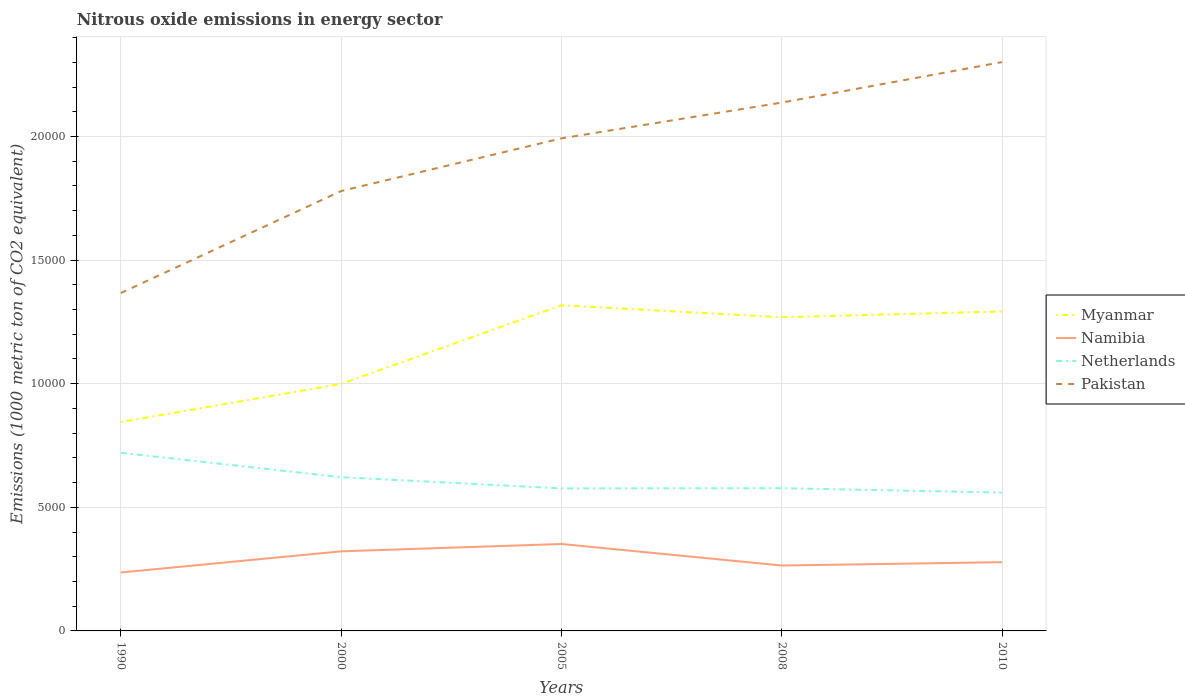How many different coloured lines are there?
Offer a terse response. 4. Does the line corresponding to Myanmar intersect with the line corresponding to Netherlands?
Offer a very short reply. No. Across all years, what is the maximum amount of nitrous oxide emitted in Namibia?
Offer a terse response. 2363.8. In which year was the amount of nitrous oxide emitted in Netherlands maximum?
Your answer should be compact. 2010. What is the total amount of nitrous oxide emitted in Namibia in the graph?
Offer a very short reply. -281.7. What is the difference between the highest and the second highest amount of nitrous oxide emitted in Netherlands?
Provide a succinct answer. 1608.7. Is the amount of nitrous oxide emitted in Namibia strictly greater than the amount of nitrous oxide emitted in Pakistan over the years?
Make the answer very short. Yes. How many lines are there?
Your answer should be compact. 4. What is the difference between two consecutive major ticks on the Y-axis?
Your answer should be compact. 5000. Does the graph contain any zero values?
Provide a short and direct response. No. Does the graph contain grids?
Offer a very short reply. Yes. Where does the legend appear in the graph?
Your answer should be compact. Center right. What is the title of the graph?
Offer a very short reply. Nitrous oxide emissions in energy sector. Does "Cameroon" appear as one of the legend labels in the graph?
Provide a short and direct response. No. What is the label or title of the X-axis?
Ensure brevity in your answer.  Years. What is the label or title of the Y-axis?
Your answer should be very brief. Emissions (1000 metric ton of CO2 equivalent). What is the Emissions (1000 metric ton of CO2 equivalent) of Myanmar in 1990?
Give a very brief answer. 8449.7. What is the Emissions (1000 metric ton of CO2 equivalent) of Namibia in 1990?
Provide a short and direct response. 2363.8. What is the Emissions (1000 metric ton of CO2 equivalent) in Netherlands in 1990?
Make the answer very short. 7205. What is the Emissions (1000 metric ton of CO2 equivalent) of Pakistan in 1990?
Make the answer very short. 1.37e+04. What is the Emissions (1000 metric ton of CO2 equivalent) of Myanmar in 2000?
Keep it short and to the point. 9992.2. What is the Emissions (1000 metric ton of CO2 equivalent) of Namibia in 2000?
Give a very brief answer. 3218.7. What is the Emissions (1000 metric ton of CO2 equivalent) in Netherlands in 2000?
Make the answer very short. 6219.5. What is the Emissions (1000 metric ton of CO2 equivalent) of Pakistan in 2000?
Make the answer very short. 1.78e+04. What is the Emissions (1000 metric ton of CO2 equivalent) of Myanmar in 2005?
Provide a succinct answer. 1.32e+04. What is the Emissions (1000 metric ton of CO2 equivalent) of Namibia in 2005?
Give a very brief answer. 3516.8. What is the Emissions (1000 metric ton of CO2 equivalent) in Netherlands in 2005?
Your answer should be very brief. 5764.8. What is the Emissions (1000 metric ton of CO2 equivalent) of Pakistan in 2005?
Provide a short and direct response. 1.99e+04. What is the Emissions (1000 metric ton of CO2 equivalent) in Myanmar in 2008?
Your answer should be compact. 1.27e+04. What is the Emissions (1000 metric ton of CO2 equivalent) in Namibia in 2008?
Offer a terse response. 2645.5. What is the Emissions (1000 metric ton of CO2 equivalent) of Netherlands in 2008?
Ensure brevity in your answer.  5773.6. What is the Emissions (1000 metric ton of CO2 equivalent) of Pakistan in 2008?
Your answer should be compact. 2.14e+04. What is the Emissions (1000 metric ton of CO2 equivalent) in Myanmar in 2010?
Your answer should be compact. 1.29e+04. What is the Emissions (1000 metric ton of CO2 equivalent) of Namibia in 2010?
Offer a terse response. 2780.9. What is the Emissions (1000 metric ton of CO2 equivalent) in Netherlands in 2010?
Provide a short and direct response. 5596.3. What is the Emissions (1000 metric ton of CO2 equivalent) in Pakistan in 2010?
Offer a terse response. 2.30e+04. Across all years, what is the maximum Emissions (1000 metric ton of CO2 equivalent) in Myanmar?
Offer a very short reply. 1.32e+04. Across all years, what is the maximum Emissions (1000 metric ton of CO2 equivalent) of Namibia?
Give a very brief answer. 3516.8. Across all years, what is the maximum Emissions (1000 metric ton of CO2 equivalent) of Netherlands?
Your response must be concise. 7205. Across all years, what is the maximum Emissions (1000 metric ton of CO2 equivalent) of Pakistan?
Provide a succinct answer. 2.30e+04. Across all years, what is the minimum Emissions (1000 metric ton of CO2 equivalent) of Myanmar?
Offer a terse response. 8449.7. Across all years, what is the minimum Emissions (1000 metric ton of CO2 equivalent) of Namibia?
Your response must be concise. 2363.8. Across all years, what is the minimum Emissions (1000 metric ton of CO2 equivalent) of Netherlands?
Ensure brevity in your answer.  5596.3. Across all years, what is the minimum Emissions (1000 metric ton of CO2 equivalent) in Pakistan?
Make the answer very short. 1.37e+04. What is the total Emissions (1000 metric ton of CO2 equivalent) in Myanmar in the graph?
Provide a succinct answer. 5.72e+04. What is the total Emissions (1000 metric ton of CO2 equivalent) in Namibia in the graph?
Make the answer very short. 1.45e+04. What is the total Emissions (1000 metric ton of CO2 equivalent) in Netherlands in the graph?
Keep it short and to the point. 3.06e+04. What is the total Emissions (1000 metric ton of CO2 equivalent) in Pakistan in the graph?
Your answer should be very brief. 9.58e+04. What is the difference between the Emissions (1000 metric ton of CO2 equivalent) of Myanmar in 1990 and that in 2000?
Make the answer very short. -1542.5. What is the difference between the Emissions (1000 metric ton of CO2 equivalent) in Namibia in 1990 and that in 2000?
Offer a terse response. -854.9. What is the difference between the Emissions (1000 metric ton of CO2 equivalent) in Netherlands in 1990 and that in 2000?
Keep it short and to the point. 985.5. What is the difference between the Emissions (1000 metric ton of CO2 equivalent) of Pakistan in 1990 and that in 2000?
Offer a terse response. -4125.3. What is the difference between the Emissions (1000 metric ton of CO2 equivalent) in Myanmar in 1990 and that in 2005?
Offer a terse response. -4721.9. What is the difference between the Emissions (1000 metric ton of CO2 equivalent) of Namibia in 1990 and that in 2005?
Give a very brief answer. -1153. What is the difference between the Emissions (1000 metric ton of CO2 equivalent) in Netherlands in 1990 and that in 2005?
Offer a terse response. 1440.2. What is the difference between the Emissions (1000 metric ton of CO2 equivalent) in Pakistan in 1990 and that in 2005?
Offer a very short reply. -6255.8. What is the difference between the Emissions (1000 metric ton of CO2 equivalent) of Myanmar in 1990 and that in 2008?
Keep it short and to the point. -4238.8. What is the difference between the Emissions (1000 metric ton of CO2 equivalent) of Namibia in 1990 and that in 2008?
Give a very brief answer. -281.7. What is the difference between the Emissions (1000 metric ton of CO2 equivalent) in Netherlands in 1990 and that in 2008?
Offer a very short reply. 1431.4. What is the difference between the Emissions (1000 metric ton of CO2 equivalent) of Pakistan in 1990 and that in 2008?
Offer a terse response. -7703.6. What is the difference between the Emissions (1000 metric ton of CO2 equivalent) in Myanmar in 1990 and that in 2010?
Offer a terse response. -4473.4. What is the difference between the Emissions (1000 metric ton of CO2 equivalent) of Namibia in 1990 and that in 2010?
Your answer should be compact. -417.1. What is the difference between the Emissions (1000 metric ton of CO2 equivalent) in Netherlands in 1990 and that in 2010?
Offer a very short reply. 1608.7. What is the difference between the Emissions (1000 metric ton of CO2 equivalent) in Pakistan in 1990 and that in 2010?
Provide a short and direct response. -9341.2. What is the difference between the Emissions (1000 metric ton of CO2 equivalent) of Myanmar in 2000 and that in 2005?
Your answer should be very brief. -3179.4. What is the difference between the Emissions (1000 metric ton of CO2 equivalent) of Namibia in 2000 and that in 2005?
Offer a very short reply. -298.1. What is the difference between the Emissions (1000 metric ton of CO2 equivalent) of Netherlands in 2000 and that in 2005?
Your answer should be very brief. 454.7. What is the difference between the Emissions (1000 metric ton of CO2 equivalent) of Pakistan in 2000 and that in 2005?
Make the answer very short. -2130.5. What is the difference between the Emissions (1000 metric ton of CO2 equivalent) of Myanmar in 2000 and that in 2008?
Your response must be concise. -2696.3. What is the difference between the Emissions (1000 metric ton of CO2 equivalent) of Namibia in 2000 and that in 2008?
Your answer should be compact. 573.2. What is the difference between the Emissions (1000 metric ton of CO2 equivalent) of Netherlands in 2000 and that in 2008?
Provide a short and direct response. 445.9. What is the difference between the Emissions (1000 metric ton of CO2 equivalent) in Pakistan in 2000 and that in 2008?
Provide a short and direct response. -3578.3. What is the difference between the Emissions (1000 metric ton of CO2 equivalent) in Myanmar in 2000 and that in 2010?
Provide a succinct answer. -2930.9. What is the difference between the Emissions (1000 metric ton of CO2 equivalent) in Namibia in 2000 and that in 2010?
Offer a very short reply. 437.8. What is the difference between the Emissions (1000 metric ton of CO2 equivalent) of Netherlands in 2000 and that in 2010?
Give a very brief answer. 623.2. What is the difference between the Emissions (1000 metric ton of CO2 equivalent) of Pakistan in 2000 and that in 2010?
Offer a very short reply. -5215.9. What is the difference between the Emissions (1000 metric ton of CO2 equivalent) of Myanmar in 2005 and that in 2008?
Offer a terse response. 483.1. What is the difference between the Emissions (1000 metric ton of CO2 equivalent) in Namibia in 2005 and that in 2008?
Keep it short and to the point. 871.3. What is the difference between the Emissions (1000 metric ton of CO2 equivalent) of Netherlands in 2005 and that in 2008?
Ensure brevity in your answer.  -8.8. What is the difference between the Emissions (1000 metric ton of CO2 equivalent) of Pakistan in 2005 and that in 2008?
Offer a very short reply. -1447.8. What is the difference between the Emissions (1000 metric ton of CO2 equivalent) in Myanmar in 2005 and that in 2010?
Make the answer very short. 248.5. What is the difference between the Emissions (1000 metric ton of CO2 equivalent) in Namibia in 2005 and that in 2010?
Give a very brief answer. 735.9. What is the difference between the Emissions (1000 metric ton of CO2 equivalent) of Netherlands in 2005 and that in 2010?
Offer a terse response. 168.5. What is the difference between the Emissions (1000 metric ton of CO2 equivalent) in Pakistan in 2005 and that in 2010?
Your answer should be compact. -3085.4. What is the difference between the Emissions (1000 metric ton of CO2 equivalent) in Myanmar in 2008 and that in 2010?
Your answer should be compact. -234.6. What is the difference between the Emissions (1000 metric ton of CO2 equivalent) of Namibia in 2008 and that in 2010?
Your answer should be very brief. -135.4. What is the difference between the Emissions (1000 metric ton of CO2 equivalent) of Netherlands in 2008 and that in 2010?
Keep it short and to the point. 177.3. What is the difference between the Emissions (1000 metric ton of CO2 equivalent) in Pakistan in 2008 and that in 2010?
Offer a terse response. -1637.6. What is the difference between the Emissions (1000 metric ton of CO2 equivalent) in Myanmar in 1990 and the Emissions (1000 metric ton of CO2 equivalent) in Namibia in 2000?
Provide a short and direct response. 5231. What is the difference between the Emissions (1000 metric ton of CO2 equivalent) in Myanmar in 1990 and the Emissions (1000 metric ton of CO2 equivalent) in Netherlands in 2000?
Your answer should be compact. 2230.2. What is the difference between the Emissions (1000 metric ton of CO2 equivalent) in Myanmar in 1990 and the Emissions (1000 metric ton of CO2 equivalent) in Pakistan in 2000?
Provide a short and direct response. -9343.8. What is the difference between the Emissions (1000 metric ton of CO2 equivalent) in Namibia in 1990 and the Emissions (1000 metric ton of CO2 equivalent) in Netherlands in 2000?
Your answer should be compact. -3855.7. What is the difference between the Emissions (1000 metric ton of CO2 equivalent) of Namibia in 1990 and the Emissions (1000 metric ton of CO2 equivalent) of Pakistan in 2000?
Ensure brevity in your answer.  -1.54e+04. What is the difference between the Emissions (1000 metric ton of CO2 equivalent) of Netherlands in 1990 and the Emissions (1000 metric ton of CO2 equivalent) of Pakistan in 2000?
Give a very brief answer. -1.06e+04. What is the difference between the Emissions (1000 metric ton of CO2 equivalent) of Myanmar in 1990 and the Emissions (1000 metric ton of CO2 equivalent) of Namibia in 2005?
Ensure brevity in your answer.  4932.9. What is the difference between the Emissions (1000 metric ton of CO2 equivalent) of Myanmar in 1990 and the Emissions (1000 metric ton of CO2 equivalent) of Netherlands in 2005?
Ensure brevity in your answer.  2684.9. What is the difference between the Emissions (1000 metric ton of CO2 equivalent) in Myanmar in 1990 and the Emissions (1000 metric ton of CO2 equivalent) in Pakistan in 2005?
Provide a short and direct response. -1.15e+04. What is the difference between the Emissions (1000 metric ton of CO2 equivalent) in Namibia in 1990 and the Emissions (1000 metric ton of CO2 equivalent) in Netherlands in 2005?
Provide a succinct answer. -3401. What is the difference between the Emissions (1000 metric ton of CO2 equivalent) of Namibia in 1990 and the Emissions (1000 metric ton of CO2 equivalent) of Pakistan in 2005?
Give a very brief answer. -1.76e+04. What is the difference between the Emissions (1000 metric ton of CO2 equivalent) in Netherlands in 1990 and the Emissions (1000 metric ton of CO2 equivalent) in Pakistan in 2005?
Make the answer very short. -1.27e+04. What is the difference between the Emissions (1000 metric ton of CO2 equivalent) of Myanmar in 1990 and the Emissions (1000 metric ton of CO2 equivalent) of Namibia in 2008?
Offer a very short reply. 5804.2. What is the difference between the Emissions (1000 metric ton of CO2 equivalent) in Myanmar in 1990 and the Emissions (1000 metric ton of CO2 equivalent) in Netherlands in 2008?
Keep it short and to the point. 2676.1. What is the difference between the Emissions (1000 metric ton of CO2 equivalent) in Myanmar in 1990 and the Emissions (1000 metric ton of CO2 equivalent) in Pakistan in 2008?
Ensure brevity in your answer.  -1.29e+04. What is the difference between the Emissions (1000 metric ton of CO2 equivalent) in Namibia in 1990 and the Emissions (1000 metric ton of CO2 equivalent) in Netherlands in 2008?
Offer a very short reply. -3409.8. What is the difference between the Emissions (1000 metric ton of CO2 equivalent) in Namibia in 1990 and the Emissions (1000 metric ton of CO2 equivalent) in Pakistan in 2008?
Your response must be concise. -1.90e+04. What is the difference between the Emissions (1000 metric ton of CO2 equivalent) in Netherlands in 1990 and the Emissions (1000 metric ton of CO2 equivalent) in Pakistan in 2008?
Your answer should be very brief. -1.42e+04. What is the difference between the Emissions (1000 metric ton of CO2 equivalent) in Myanmar in 1990 and the Emissions (1000 metric ton of CO2 equivalent) in Namibia in 2010?
Give a very brief answer. 5668.8. What is the difference between the Emissions (1000 metric ton of CO2 equivalent) of Myanmar in 1990 and the Emissions (1000 metric ton of CO2 equivalent) of Netherlands in 2010?
Your response must be concise. 2853.4. What is the difference between the Emissions (1000 metric ton of CO2 equivalent) in Myanmar in 1990 and the Emissions (1000 metric ton of CO2 equivalent) in Pakistan in 2010?
Your answer should be very brief. -1.46e+04. What is the difference between the Emissions (1000 metric ton of CO2 equivalent) in Namibia in 1990 and the Emissions (1000 metric ton of CO2 equivalent) in Netherlands in 2010?
Your answer should be compact. -3232.5. What is the difference between the Emissions (1000 metric ton of CO2 equivalent) in Namibia in 1990 and the Emissions (1000 metric ton of CO2 equivalent) in Pakistan in 2010?
Offer a very short reply. -2.06e+04. What is the difference between the Emissions (1000 metric ton of CO2 equivalent) in Netherlands in 1990 and the Emissions (1000 metric ton of CO2 equivalent) in Pakistan in 2010?
Make the answer very short. -1.58e+04. What is the difference between the Emissions (1000 metric ton of CO2 equivalent) of Myanmar in 2000 and the Emissions (1000 metric ton of CO2 equivalent) of Namibia in 2005?
Provide a succinct answer. 6475.4. What is the difference between the Emissions (1000 metric ton of CO2 equivalent) in Myanmar in 2000 and the Emissions (1000 metric ton of CO2 equivalent) in Netherlands in 2005?
Your answer should be compact. 4227.4. What is the difference between the Emissions (1000 metric ton of CO2 equivalent) in Myanmar in 2000 and the Emissions (1000 metric ton of CO2 equivalent) in Pakistan in 2005?
Provide a short and direct response. -9931.8. What is the difference between the Emissions (1000 metric ton of CO2 equivalent) of Namibia in 2000 and the Emissions (1000 metric ton of CO2 equivalent) of Netherlands in 2005?
Give a very brief answer. -2546.1. What is the difference between the Emissions (1000 metric ton of CO2 equivalent) in Namibia in 2000 and the Emissions (1000 metric ton of CO2 equivalent) in Pakistan in 2005?
Make the answer very short. -1.67e+04. What is the difference between the Emissions (1000 metric ton of CO2 equivalent) of Netherlands in 2000 and the Emissions (1000 metric ton of CO2 equivalent) of Pakistan in 2005?
Ensure brevity in your answer.  -1.37e+04. What is the difference between the Emissions (1000 metric ton of CO2 equivalent) of Myanmar in 2000 and the Emissions (1000 metric ton of CO2 equivalent) of Namibia in 2008?
Your answer should be compact. 7346.7. What is the difference between the Emissions (1000 metric ton of CO2 equivalent) in Myanmar in 2000 and the Emissions (1000 metric ton of CO2 equivalent) in Netherlands in 2008?
Provide a succinct answer. 4218.6. What is the difference between the Emissions (1000 metric ton of CO2 equivalent) in Myanmar in 2000 and the Emissions (1000 metric ton of CO2 equivalent) in Pakistan in 2008?
Make the answer very short. -1.14e+04. What is the difference between the Emissions (1000 metric ton of CO2 equivalent) of Namibia in 2000 and the Emissions (1000 metric ton of CO2 equivalent) of Netherlands in 2008?
Your answer should be very brief. -2554.9. What is the difference between the Emissions (1000 metric ton of CO2 equivalent) of Namibia in 2000 and the Emissions (1000 metric ton of CO2 equivalent) of Pakistan in 2008?
Offer a terse response. -1.82e+04. What is the difference between the Emissions (1000 metric ton of CO2 equivalent) of Netherlands in 2000 and the Emissions (1000 metric ton of CO2 equivalent) of Pakistan in 2008?
Keep it short and to the point. -1.52e+04. What is the difference between the Emissions (1000 metric ton of CO2 equivalent) of Myanmar in 2000 and the Emissions (1000 metric ton of CO2 equivalent) of Namibia in 2010?
Provide a succinct answer. 7211.3. What is the difference between the Emissions (1000 metric ton of CO2 equivalent) in Myanmar in 2000 and the Emissions (1000 metric ton of CO2 equivalent) in Netherlands in 2010?
Provide a short and direct response. 4395.9. What is the difference between the Emissions (1000 metric ton of CO2 equivalent) in Myanmar in 2000 and the Emissions (1000 metric ton of CO2 equivalent) in Pakistan in 2010?
Give a very brief answer. -1.30e+04. What is the difference between the Emissions (1000 metric ton of CO2 equivalent) of Namibia in 2000 and the Emissions (1000 metric ton of CO2 equivalent) of Netherlands in 2010?
Provide a succinct answer. -2377.6. What is the difference between the Emissions (1000 metric ton of CO2 equivalent) in Namibia in 2000 and the Emissions (1000 metric ton of CO2 equivalent) in Pakistan in 2010?
Offer a very short reply. -1.98e+04. What is the difference between the Emissions (1000 metric ton of CO2 equivalent) of Netherlands in 2000 and the Emissions (1000 metric ton of CO2 equivalent) of Pakistan in 2010?
Your response must be concise. -1.68e+04. What is the difference between the Emissions (1000 metric ton of CO2 equivalent) in Myanmar in 2005 and the Emissions (1000 metric ton of CO2 equivalent) in Namibia in 2008?
Make the answer very short. 1.05e+04. What is the difference between the Emissions (1000 metric ton of CO2 equivalent) in Myanmar in 2005 and the Emissions (1000 metric ton of CO2 equivalent) in Netherlands in 2008?
Ensure brevity in your answer.  7398. What is the difference between the Emissions (1000 metric ton of CO2 equivalent) in Myanmar in 2005 and the Emissions (1000 metric ton of CO2 equivalent) in Pakistan in 2008?
Provide a succinct answer. -8200.2. What is the difference between the Emissions (1000 metric ton of CO2 equivalent) in Namibia in 2005 and the Emissions (1000 metric ton of CO2 equivalent) in Netherlands in 2008?
Keep it short and to the point. -2256.8. What is the difference between the Emissions (1000 metric ton of CO2 equivalent) of Namibia in 2005 and the Emissions (1000 metric ton of CO2 equivalent) of Pakistan in 2008?
Provide a short and direct response. -1.79e+04. What is the difference between the Emissions (1000 metric ton of CO2 equivalent) of Netherlands in 2005 and the Emissions (1000 metric ton of CO2 equivalent) of Pakistan in 2008?
Provide a succinct answer. -1.56e+04. What is the difference between the Emissions (1000 metric ton of CO2 equivalent) in Myanmar in 2005 and the Emissions (1000 metric ton of CO2 equivalent) in Namibia in 2010?
Give a very brief answer. 1.04e+04. What is the difference between the Emissions (1000 metric ton of CO2 equivalent) of Myanmar in 2005 and the Emissions (1000 metric ton of CO2 equivalent) of Netherlands in 2010?
Give a very brief answer. 7575.3. What is the difference between the Emissions (1000 metric ton of CO2 equivalent) of Myanmar in 2005 and the Emissions (1000 metric ton of CO2 equivalent) of Pakistan in 2010?
Keep it short and to the point. -9837.8. What is the difference between the Emissions (1000 metric ton of CO2 equivalent) in Namibia in 2005 and the Emissions (1000 metric ton of CO2 equivalent) in Netherlands in 2010?
Your answer should be very brief. -2079.5. What is the difference between the Emissions (1000 metric ton of CO2 equivalent) of Namibia in 2005 and the Emissions (1000 metric ton of CO2 equivalent) of Pakistan in 2010?
Offer a very short reply. -1.95e+04. What is the difference between the Emissions (1000 metric ton of CO2 equivalent) of Netherlands in 2005 and the Emissions (1000 metric ton of CO2 equivalent) of Pakistan in 2010?
Provide a succinct answer. -1.72e+04. What is the difference between the Emissions (1000 metric ton of CO2 equivalent) in Myanmar in 2008 and the Emissions (1000 metric ton of CO2 equivalent) in Namibia in 2010?
Provide a succinct answer. 9907.6. What is the difference between the Emissions (1000 metric ton of CO2 equivalent) in Myanmar in 2008 and the Emissions (1000 metric ton of CO2 equivalent) in Netherlands in 2010?
Give a very brief answer. 7092.2. What is the difference between the Emissions (1000 metric ton of CO2 equivalent) in Myanmar in 2008 and the Emissions (1000 metric ton of CO2 equivalent) in Pakistan in 2010?
Provide a succinct answer. -1.03e+04. What is the difference between the Emissions (1000 metric ton of CO2 equivalent) of Namibia in 2008 and the Emissions (1000 metric ton of CO2 equivalent) of Netherlands in 2010?
Provide a succinct answer. -2950.8. What is the difference between the Emissions (1000 metric ton of CO2 equivalent) in Namibia in 2008 and the Emissions (1000 metric ton of CO2 equivalent) in Pakistan in 2010?
Ensure brevity in your answer.  -2.04e+04. What is the difference between the Emissions (1000 metric ton of CO2 equivalent) in Netherlands in 2008 and the Emissions (1000 metric ton of CO2 equivalent) in Pakistan in 2010?
Your response must be concise. -1.72e+04. What is the average Emissions (1000 metric ton of CO2 equivalent) in Myanmar per year?
Keep it short and to the point. 1.14e+04. What is the average Emissions (1000 metric ton of CO2 equivalent) in Namibia per year?
Offer a terse response. 2905.14. What is the average Emissions (1000 metric ton of CO2 equivalent) of Netherlands per year?
Keep it short and to the point. 6111.84. What is the average Emissions (1000 metric ton of CO2 equivalent) in Pakistan per year?
Provide a succinct answer. 1.92e+04. In the year 1990, what is the difference between the Emissions (1000 metric ton of CO2 equivalent) in Myanmar and Emissions (1000 metric ton of CO2 equivalent) in Namibia?
Your answer should be very brief. 6085.9. In the year 1990, what is the difference between the Emissions (1000 metric ton of CO2 equivalent) in Myanmar and Emissions (1000 metric ton of CO2 equivalent) in Netherlands?
Provide a short and direct response. 1244.7. In the year 1990, what is the difference between the Emissions (1000 metric ton of CO2 equivalent) in Myanmar and Emissions (1000 metric ton of CO2 equivalent) in Pakistan?
Your answer should be compact. -5218.5. In the year 1990, what is the difference between the Emissions (1000 metric ton of CO2 equivalent) in Namibia and Emissions (1000 metric ton of CO2 equivalent) in Netherlands?
Ensure brevity in your answer.  -4841.2. In the year 1990, what is the difference between the Emissions (1000 metric ton of CO2 equivalent) of Namibia and Emissions (1000 metric ton of CO2 equivalent) of Pakistan?
Your response must be concise. -1.13e+04. In the year 1990, what is the difference between the Emissions (1000 metric ton of CO2 equivalent) in Netherlands and Emissions (1000 metric ton of CO2 equivalent) in Pakistan?
Keep it short and to the point. -6463.2. In the year 2000, what is the difference between the Emissions (1000 metric ton of CO2 equivalent) of Myanmar and Emissions (1000 metric ton of CO2 equivalent) of Namibia?
Provide a succinct answer. 6773.5. In the year 2000, what is the difference between the Emissions (1000 metric ton of CO2 equivalent) in Myanmar and Emissions (1000 metric ton of CO2 equivalent) in Netherlands?
Ensure brevity in your answer.  3772.7. In the year 2000, what is the difference between the Emissions (1000 metric ton of CO2 equivalent) of Myanmar and Emissions (1000 metric ton of CO2 equivalent) of Pakistan?
Make the answer very short. -7801.3. In the year 2000, what is the difference between the Emissions (1000 metric ton of CO2 equivalent) in Namibia and Emissions (1000 metric ton of CO2 equivalent) in Netherlands?
Your answer should be compact. -3000.8. In the year 2000, what is the difference between the Emissions (1000 metric ton of CO2 equivalent) in Namibia and Emissions (1000 metric ton of CO2 equivalent) in Pakistan?
Make the answer very short. -1.46e+04. In the year 2000, what is the difference between the Emissions (1000 metric ton of CO2 equivalent) of Netherlands and Emissions (1000 metric ton of CO2 equivalent) of Pakistan?
Provide a short and direct response. -1.16e+04. In the year 2005, what is the difference between the Emissions (1000 metric ton of CO2 equivalent) in Myanmar and Emissions (1000 metric ton of CO2 equivalent) in Namibia?
Your response must be concise. 9654.8. In the year 2005, what is the difference between the Emissions (1000 metric ton of CO2 equivalent) in Myanmar and Emissions (1000 metric ton of CO2 equivalent) in Netherlands?
Offer a terse response. 7406.8. In the year 2005, what is the difference between the Emissions (1000 metric ton of CO2 equivalent) of Myanmar and Emissions (1000 metric ton of CO2 equivalent) of Pakistan?
Your answer should be compact. -6752.4. In the year 2005, what is the difference between the Emissions (1000 metric ton of CO2 equivalent) of Namibia and Emissions (1000 metric ton of CO2 equivalent) of Netherlands?
Offer a terse response. -2248. In the year 2005, what is the difference between the Emissions (1000 metric ton of CO2 equivalent) in Namibia and Emissions (1000 metric ton of CO2 equivalent) in Pakistan?
Ensure brevity in your answer.  -1.64e+04. In the year 2005, what is the difference between the Emissions (1000 metric ton of CO2 equivalent) in Netherlands and Emissions (1000 metric ton of CO2 equivalent) in Pakistan?
Provide a succinct answer. -1.42e+04. In the year 2008, what is the difference between the Emissions (1000 metric ton of CO2 equivalent) of Myanmar and Emissions (1000 metric ton of CO2 equivalent) of Namibia?
Make the answer very short. 1.00e+04. In the year 2008, what is the difference between the Emissions (1000 metric ton of CO2 equivalent) in Myanmar and Emissions (1000 metric ton of CO2 equivalent) in Netherlands?
Offer a very short reply. 6914.9. In the year 2008, what is the difference between the Emissions (1000 metric ton of CO2 equivalent) in Myanmar and Emissions (1000 metric ton of CO2 equivalent) in Pakistan?
Provide a succinct answer. -8683.3. In the year 2008, what is the difference between the Emissions (1000 metric ton of CO2 equivalent) of Namibia and Emissions (1000 metric ton of CO2 equivalent) of Netherlands?
Offer a very short reply. -3128.1. In the year 2008, what is the difference between the Emissions (1000 metric ton of CO2 equivalent) in Namibia and Emissions (1000 metric ton of CO2 equivalent) in Pakistan?
Provide a short and direct response. -1.87e+04. In the year 2008, what is the difference between the Emissions (1000 metric ton of CO2 equivalent) of Netherlands and Emissions (1000 metric ton of CO2 equivalent) of Pakistan?
Keep it short and to the point. -1.56e+04. In the year 2010, what is the difference between the Emissions (1000 metric ton of CO2 equivalent) of Myanmar and Emissions (1000 metric ton of CO2 equivalent) of Namibia?
Your answer should be compact. 1.01e+04. In the year 2010, what is the difference between the Emissions (1000 metric ton of CO2 equivalent) in Myanmar and Emissions (1000 metric ton of CO2 equivalent) in Netherlands?
Give a very brief answer. 7326.8. In the year 2010, what is the difference between the Emissions (1000 metric ton of CO2 equivalent) of Myanmar and Emissions (1000 metric ton of CO2 equivalent) of Pakistan?
Provide a succinct answer. -1.01e+04. In the year 2010, what is the difference between the Emissions (1000 metric ton of CO2 equivalent) in Namibia and Emissions (1000 metric ton of CO2 equivalent) in Netherlands?
Provide a succinct answer. -2815.4. In the year 2010, what is the difference between the Emissions (1000 metric ton of CO2 equivalent) of Namibia and Emissions (1000 metric ton of CO2 equivalent) of Pakistan?
Your answer should be compact. -2.02e+04. In the year 2010, what is the difference between the Emissions (1000 metric ton of CO2 equivalent) of Netherlands and Emissions (1000 metric ton of CO2 equivalent) of Pakistan?
Give a very brief answer. -1.74e+04. What is the ratio of the Emissions (1000 metric ton of CO2 equivalent) of Myanmar in 1990 to that in 2000?
Provide a short and direct response. 0.85. What is the ratio of the Emissions (1000 metric ton of CO2 equivalent) in Namibia in 1990 to that in 2000?
Your answer should be compact. 0.73. What is the ratio of the Emissions (1000 metric ton of CO2 equivalent) of Netherlands in 1990 to that in 2000?
Provide a short and direct response. 1.16. What is the ratio of the Emissions (1000 metric ton of CO2 equivalent) in Pakistan in 1990 to that in 2000?
Give a very brief answer. 0.77. What is the ratio of the Emissions (1000 metric ton of CO2 equivalent) in Myanmar in 1990 to that in 2005?
Your answer should be compact. 0.64. What is the ratio of the Emissions (1000 metric ton of CO2 equivalent) of Namibia in 1990 to that in 2005?
Provide a short and direct response. 0.67. What is the ratio of the Emissions (1000 metric ton of CO2 equivalent) in Netherlands in 1990 to that in 2005?
Your answer should be very brief. 1.25. What is the ratio of the Emissions (1000 metric ton of CO2 equivalent) in Pakistan in 1990 to that in 2005?
Keep it short and to the point. 0.69. What is the ratio of the Emissions (1000 metric ton of CO2 equivalent) in Myanmar in 1990 to that in 2008?
Keep it short and to the point. 0.67. What is the ratio of the Emissions (1000 metric ton of CO2 equivalent) of Namibia in 1990 to that in 2008?
Keep it short and to the point. 0.89. What is the ratio of the Emissions (1000 metric ton of CO2 equivalent) in Netherlands in 1990 to that in 2008?
Give a very brief answer. 1.25. What is the ratio of the Emissions (1000 metric ton of CO2 equivalent) in Pakistan in 1990 to that in 2008?
Offer a terse response. 0.64. What is the ratio of the Emissions (1000 metric ton of CO2 equivalent) of Myanmar in 1990 to that in 2010?
Offer a very short reply. 0.65. What is the ratio of the Emissions (1000 metric ton of CO2 equivalent) of Netherlands in 1990 to that in 2010?
Offer a terse response. 1.29. What is the ratio of the Emissions (1000 metric ton of CO2 equivalent) in Pakistan in 1990 to that in 2010?
Your answer should be very brief. 0.59. What is the ratio of the Emissions (1000 metric ton of CO2 equivalent) in Myanmar in 2000 to that in 2005?
Offer a very short reply. 0.76. What is the ratio of the Emissions (1000 metric ton of CO2 equivalent) of Namibia in 2000 to that in 2005?
Your response must be concise. 0.92. What is the ratio of the Emissions (1000 metric ton of CO2 equivalent) in Netherlands in 2000 to that in 2005?
Provide a succinct answer. 1.08. What is the ratio of the Emissions (1000 metric ton of CO2 equivalent) in Pakistan in 2000 to that in 2005?
Your answer should be very brief. 0.89. What is the ratio of the Emissions (1000 metric ton of CO2 equivalent) of Myanmar in 2000 to that in 2008?
Your answer should be very brief. 0.79. What is the ratio of the Emissions (1000 metric ton of CO2 equivalent) in Namibia in 2000 to that in 2008?
Provide a short and direct response. 1.22. What is the ratio of the Emissions (1000 metric ton of CO2 equivalent) of Netherlands in 2000 to that in 2008?
Give a very brief answer. 1.08. What is the ratio of the Emissions (1000 metric ton of CO2 equivalent) in Pakistan in 2000 to that in 2008?
Give a very brief answer. 0.83. What is the ratio of the Emissions (1000 metric ton of CO2 equivalent) in Myanmar in 2000 to that in 2010?
Your response must be concise. 0.77. What is the ratio of the Emissions (1000 metric ton of CO2 equivalent) of Namibia in 2000 to that in 2010?
Your answer should be compact. 1.16. What is the ratio of the Emissions (1000 metric ton of CO2 equivalent) of Netherlands in 2000 to that in 2010?
Give a very brief answer. 1.11. What is the ratio of the Emissions (1000 metric ton of CO2 equivalent) of Pakistan in 2000 to that in 2010?
Offer a terse response. 0.77. What is the ratio of the Emissions (1000 metric ton of CO2 equivalent) of Myanmar in 2005 to that in 2008?
Provide a short and direct response. 1.04. What is the ratio of the Emissions (1000 metric ton of CO2 equivalent) of Namibia in 2005 to that in 2008?
Make the answer very short. 1.33. What is the ratio of the Emissions (1000 metric ton of CO2 equivalent) in Netherlands in 2005 to that in 2008?
Your answer should be very brief. 1. What is the ratio of the Emissions (1000 metric ton of CO2 equivalent) in Pakistan in 2005 to that in 2008?
Offer a very short reply. 0.93. What is the ratio of the Emissions (1000 metric ton of CO2 equivalent) of Myanmar in 2005 to that in 2010?
Ensure brevity in your answer.  1.02. What is the ratio of the Emissions (1000 metric ton of CO2 equivalent) in Namibia in 2005 to that in 2010?
Ensure brevity in your answer.  1.26. What is the ratio of the Emissions (1000 metric ton of CO2 equivalent) in Netherlands in 2005 to that in 2010?
Provide a succinct answer. 1.03. What is the ratio of the Emissions (1000 metric ton of CO2 equivalent) in Pakistan in 2005 to that in 2010?
Keep it short and to the point. 0.87. What is the ratio of the Emissions (1000 metric ton of CO2 equivalent) of Myanmar in 2008 to that in 2010?
Make the answer very short. 0.98. What is the ratio of the Emissions (1000 metric ton of CO2 equivalent) in Namibia in 2008 to that in 2010?
Make the answer very short. 0.95. What is the ratio of the Emissions (1000 metric ton of CO2 equivalent) of Netherlands in 2008 to that in 2010?
Give a very brief answer. 1.03. What is the ratio of the Emissions (1000 metric ton of CO2 equivalent) of Pakistan in 2008 to that in 2010?
Your answer should be compact. 0.93. What is the difference between the highest and the second highest Emissions (1000 metric ton of CO2 equivalent) in Myanmar?
Offer a terse response. 248.5. What is the difference between the highest and the second highest Emissions (1000 metric ton of CO2 equivalent) of Namibia?
Ensure brevity in your answer.  298.1. What is the difference between the highest and the second highest Emissions (1000 metric ton of CO2 equivalent) of Netherlands?
Your answer should be compact. 985.5. What is the difference between the highest and the second highest Emissions (1000 metric ton of CO2 equivalent) of Pakistan?
Offer a terse response. 1637.6. What is the difference between the highest and the lowest Emissions (1000 metric ton of CO2 equivalent) in Myanmar?
Offer a very short reply. 4721.9. What is the difference between the highest and the lowest Emissions (1000 metric ton of CO2 equivalent) of Namibia?
Your response must be concise. 1153. What is the difference between the highest and the lowest Emissions (1000 metric ton of CO2 equivalent) in Netherlands?
Give a very brief answer. 1608.7. What is the difference between the highest and the lowest Emissions (1000 metric ton of CO2 equivalent) of Pakistan?
Provide a short and direct response. 9341.2. 